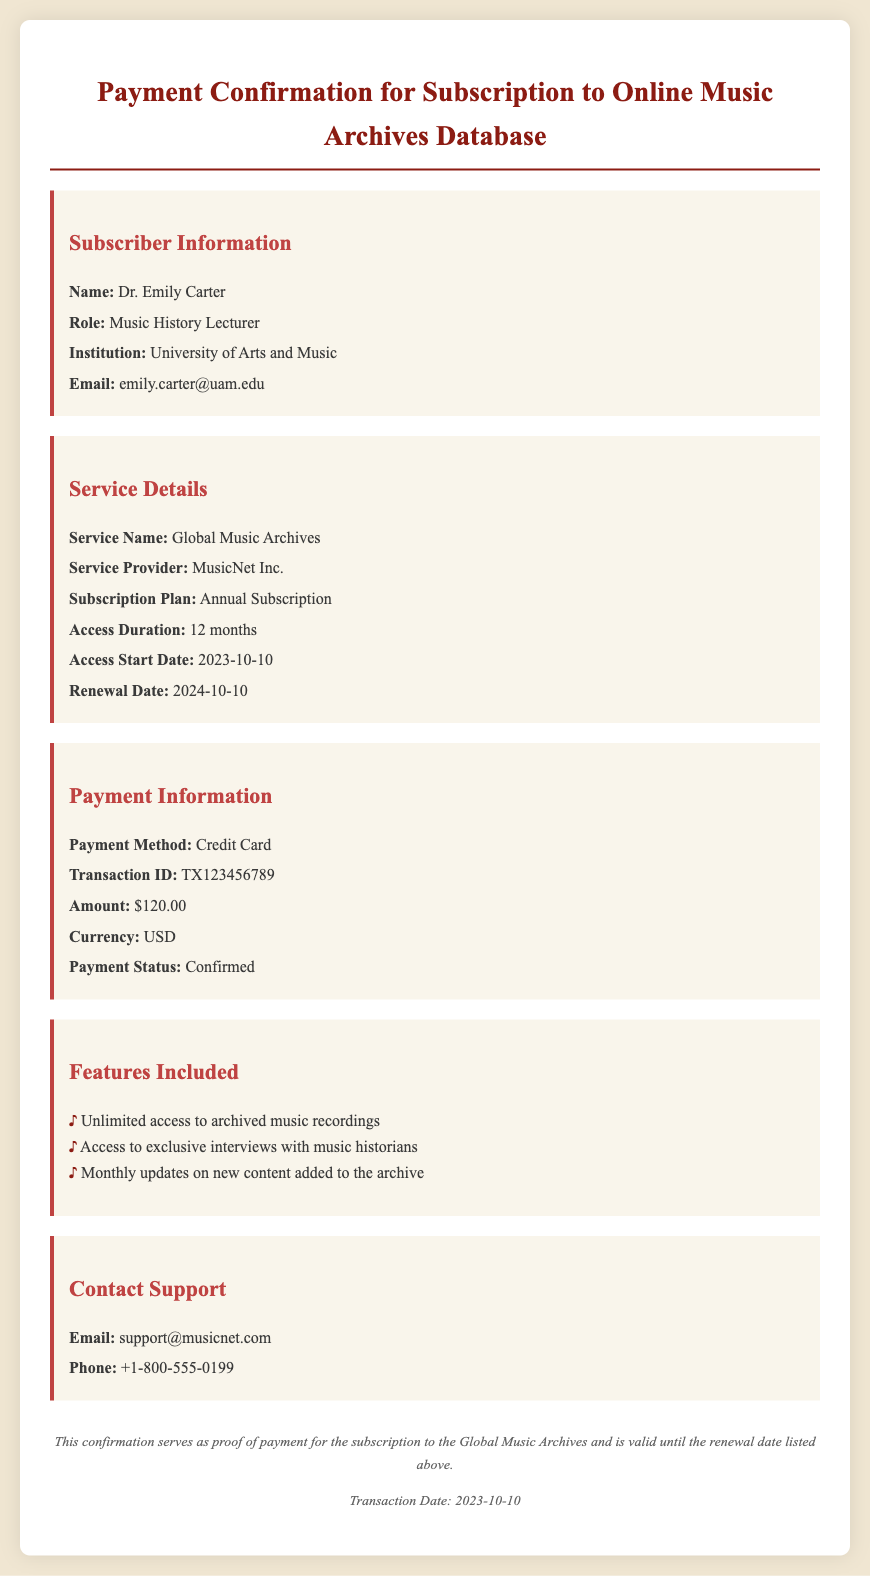What is the subscriber's name? The subscriber's name is mentioned under Subscriber Information in the document.
Answer: Dr. Emily Carter What is the subscription plan? The subscription plan is specified in the Service Details section of the document.
Answer: Annual Subscription What is the access duration? The access duration is highlighted in the Service Details section of the document.
Answer: 12 months What is the renewal date? The renewal date is mentioned in the Service Details section of the document.
Answer: 2024-10-10 What is the payment amount? The payment amount is included under the Payment Information section of the document.
Answer: $120.00 Which service provider is listed? The service provider is outlined in the Service Details section of the document.
Answer: MusicNet Inc How was the payment made? The payment method is specified in the Payment Information section of the document.
Answer: Credit Card What is the email for support contact? The support email is provided in the Contact Support section of the document.
Answer: support@musicnet.com What is the transaction date? The transaction date is noted in the footer of the document.
Answer: 2023-10-10 